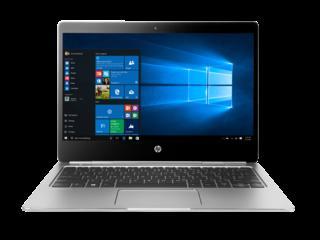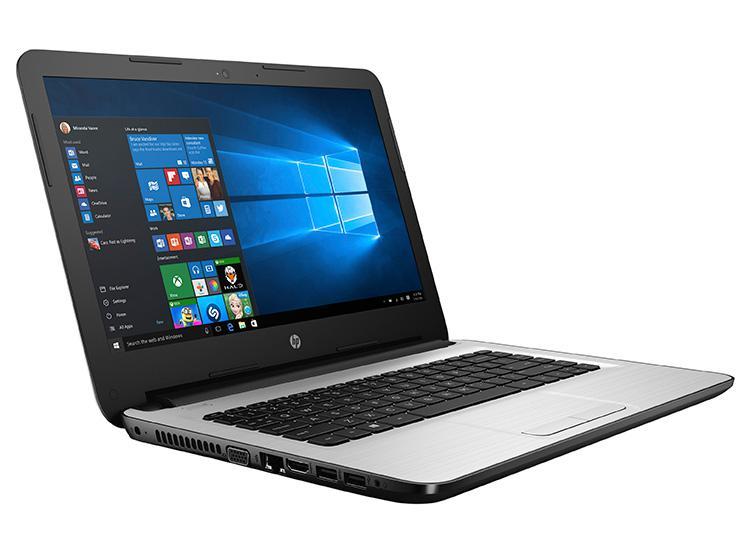The first image is the image on the left, the second image is the image on the right. Evaluate the accuracy of this statement regarding the images: "The laptop in the right image is displayed turned at an angle.". Is it true? Answer yes or no. Yes. 